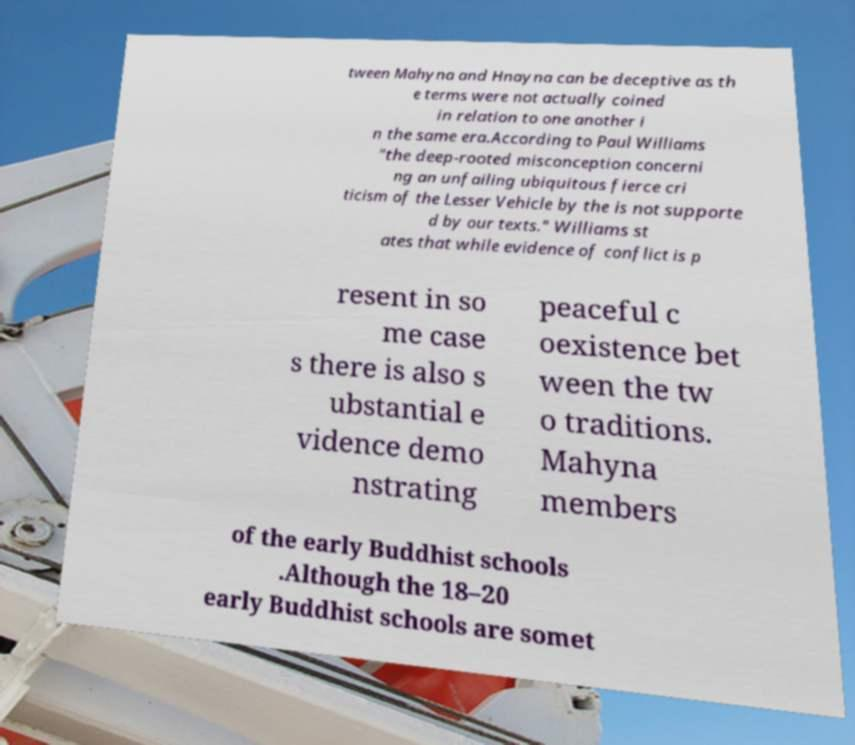Can you read and provide the text displayed in the image?This photo seems to have some interesting text. Can you extract and type it out for me? tween Mahyna and Hnayna can be deceptive as th e terms were not actually coined in relation to one another i n the same era.According to Paul Williams "the deep-rooted misconception concerni ng an unfailing ubiquitous fierce cri ticism of the Lesser Vehicle by the is not supporte d by our texts." Williams st ates that while evidence of conflict is p resent in so me case s there is also s ubstantial e vidence demo nstrating peaceful c oexistence bet ween the tw o traditions. Mahyna members of the early Buddhist schools .Although the 18–20 early Buddhist schools are somet 